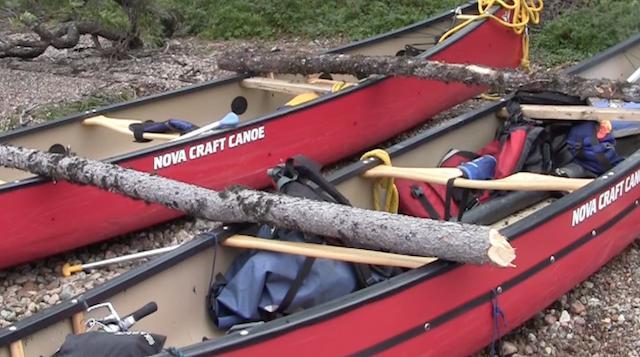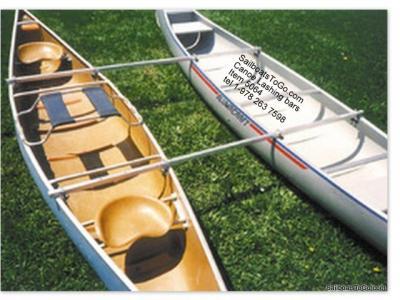The first image is the image on the left, the second image is the image on the right. Evaluate the accuracy of this statement regarding the images: "Both images show multiple people inside a double-rigger canoe that is at least partially on the water.". Is it true? Answer yes or no. No. The first image is the image on the left, the second image is the image on the right. Considering the images on both sides, is "There is an American flag on the boat in the image on the left." valid? Answer yes or no. No. 